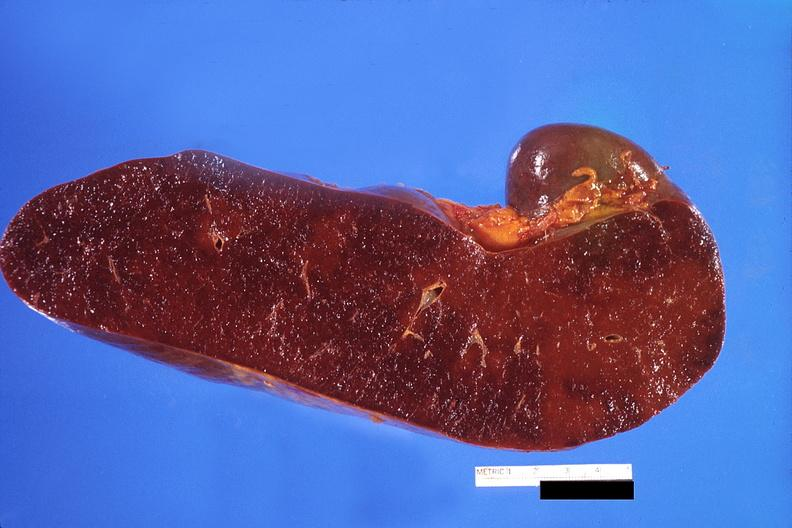what is present?
Answer the question using a single word or phrase. Hematologic 